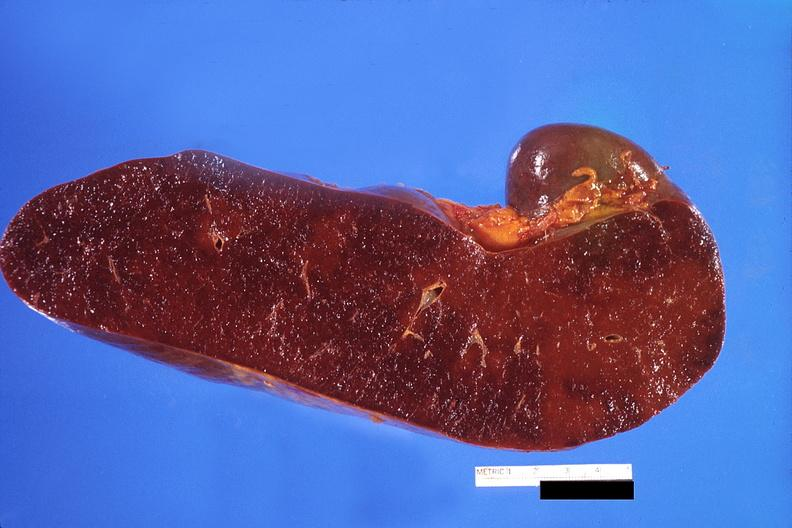what is present?
Answer the question using a single word or phrase. Hematologic 